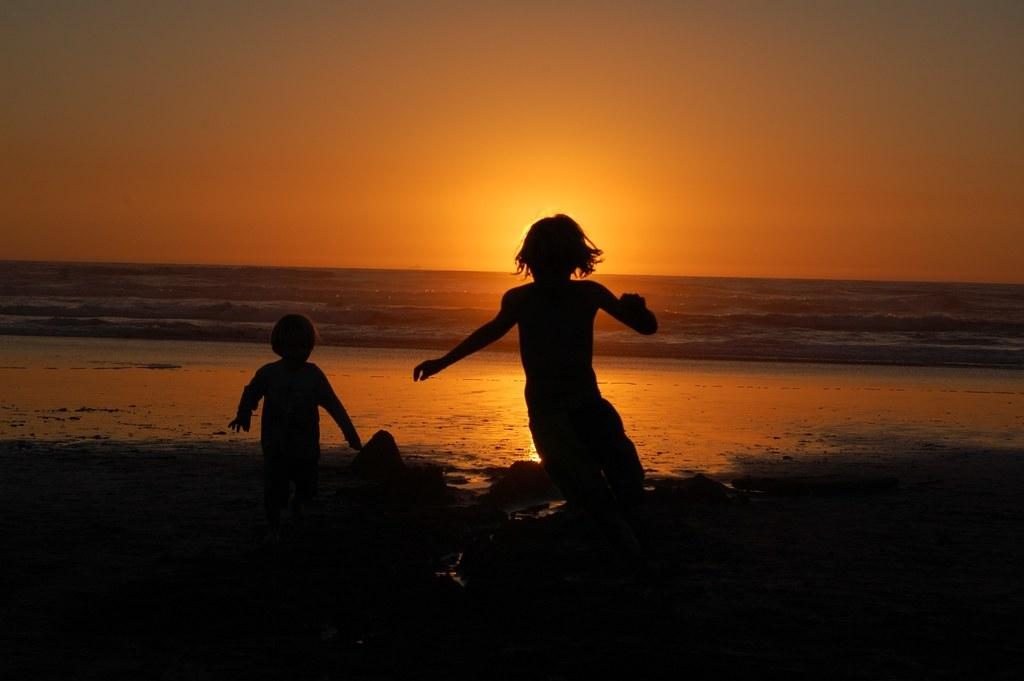How many people are in the image? There are two persons in the image. What are the persons doing in the image? The persons are in motion on the sand. What can be seen in the background of the image? There is water and the sky visible in the background of the image. What book is the aunt reading in the image? There is no aunt or book present in the image. What is the head of the person doing in the image? There is no specific action involving the head of the person mentioned in the image. 